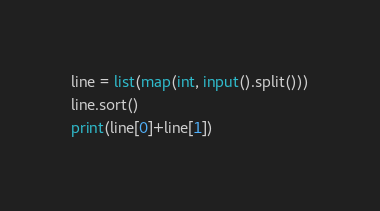Convert code to text. <code><loc_0><loc_0><loc_500><loc_500><_Python_>line = list(map(int, input().split()))
line.sort()
print(line[0]+line[1])</code> 